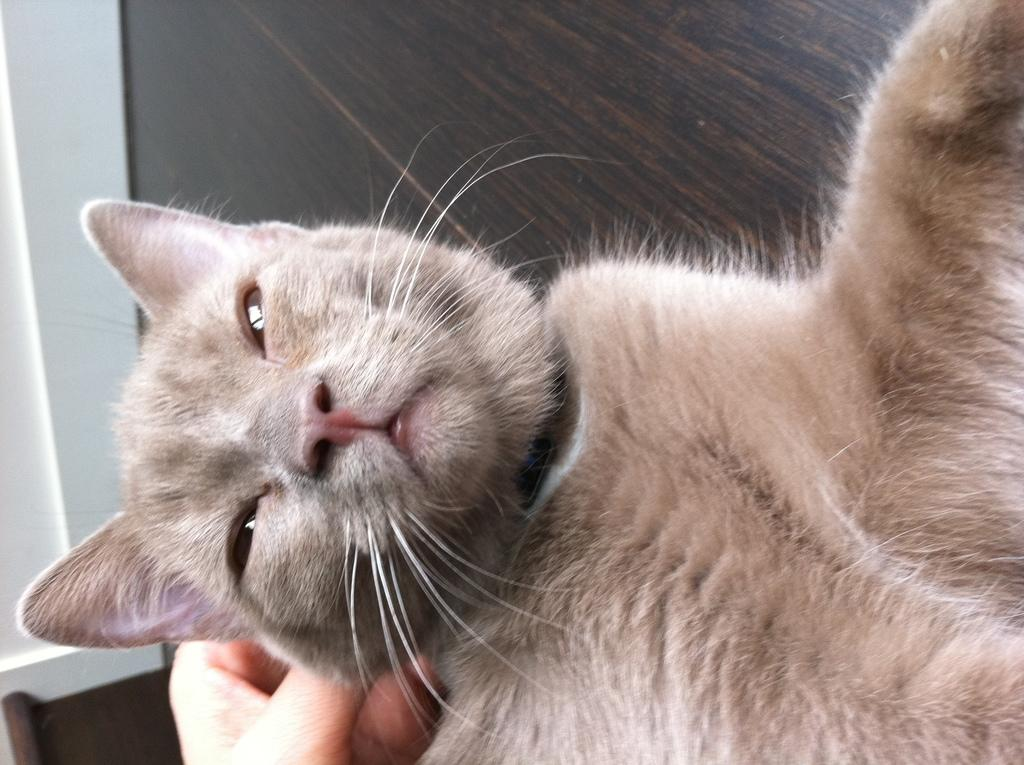What type of animal is in the image? There is a cat in the image. Can you describe any human presence in the image? A person's hand is visible in the image. How many babies are visible in the image? There are no babies visible in the image. What type of liquid can be seen in the image? There is no liquid present in the image. Is there a tiger in the image? No, there is no tiger in the image; it features a cat. 